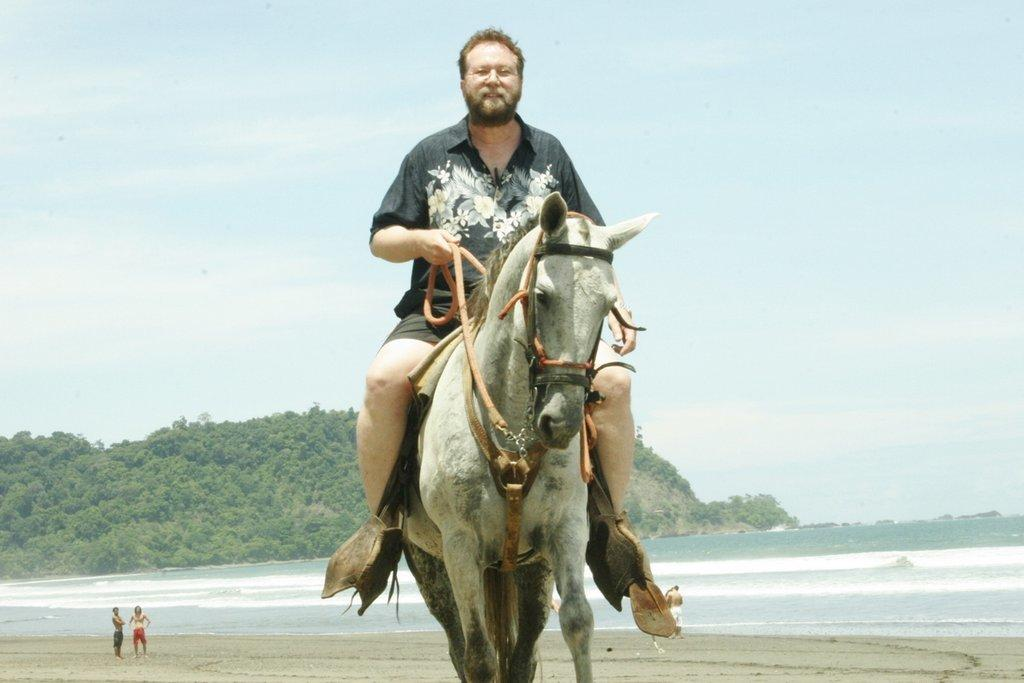What is the main subject in the foreground of the image? There is a man on a horse in the foreground of the image. Can you describe the setting of the image? The scene appears to be at a beach. What can be seen in the background of the image? There is a mountain visible in the background, and the sky is also visible. How many people are present in the image? There are people in the image, but the exact number is not specified. What type of shoe is the man on the horse wearing in the image? There is no information about the man's footwear in the image, so we cannot determine what type of shoe he is wearing. 